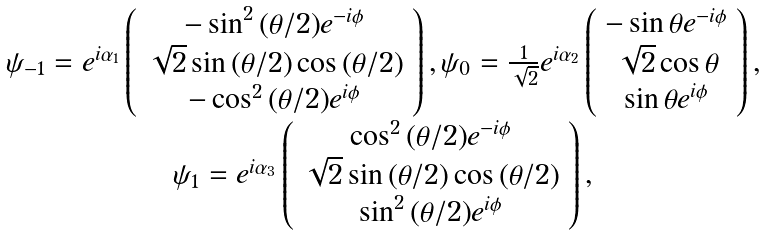Convert formula to latex. <formula><loc_0><loc_0><loc_500><loc_500>\begin{array} { c } \psi _ { - 1 } = e ^ { i \alpha _ { 1 } } \left ( \begin{array} { c } - \sin ^ { 2 } { ( \theta / 2 ) } e ^ { - i \phi } \\ \sqrt { 2 } \sin { ( \theta / 2 ) } \cos { ( \theta / 2 ) } \\ - \cos ^ { 2 } { ( \theta / 2 ) } e ^ { i \phi } \end{array} \right ) , \psi _ { 0 } = \frac { 1 } { \sqrt { 2 } } e ^ { i \alpha _ { 2 } } \left ( \begin{array} { c } - \sin { \theta } e ^ { - i \phi } \\ \sqrt { 2 } \cos { \theta } \\ \sin { \theta } e ^ { i \phi } \end{array} \right ) , \\ \psi _ { 1 } = e ^ { i \alpha _ { 3 } } \left ( \begin{array} { c } \cos ^ { 2 } { ( \theta / 2 ) } e ^ { - i \phi } \\ \sqrt { 2 } \sin { ( \theta / 2 ) } \cos { ( \theta / 2 ) } \\ \sin ^ { 2 } { ( \theta / 2 ) } e ^ { i \phi } \end{array} \right ) , \end{array}</formula> 